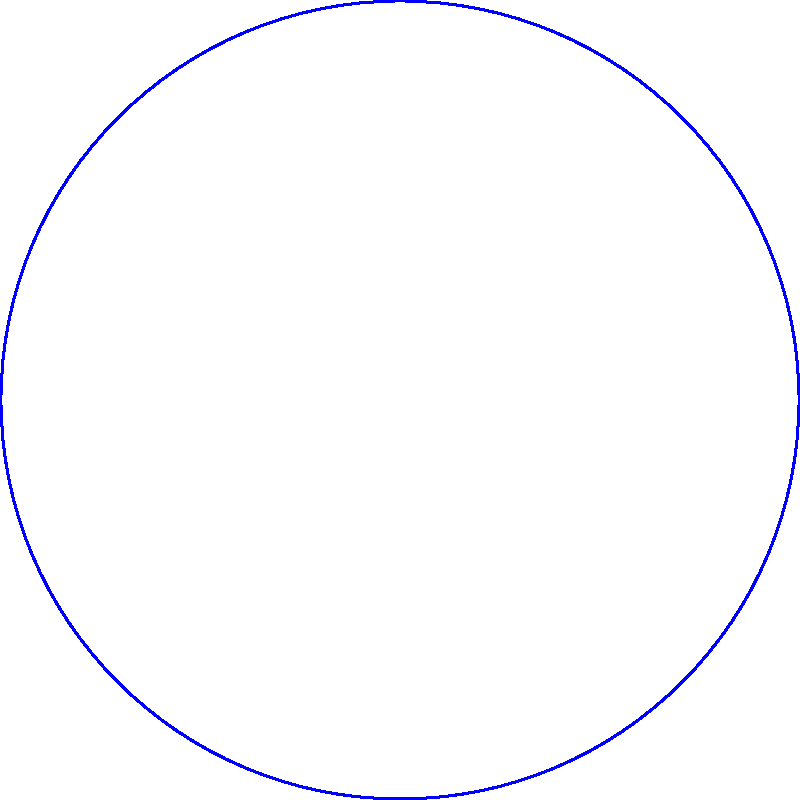Consider a positively charged particle with charge $+q$ at the origin O. The electric field lines are shown in blue. If we apply a translation of 2 units to the right, transforming the particle to point A, how would the electric field lines be affected? Describe the transformation of the field lines and explain why this occurs. To understand the transformation of electric field lines, let's follow these steps:

1) Initial configuration: The electric field lines originate radially outward from the positive charge $+q$ at the origin O.

2) Translation: The charge is moved 2 units to the right, to point A.

3) Effect on field lines:
   a) The field lines will maintain their radial pattern.
   b) The center of the radial pattern will move with the charge to point A.
   c) The field lines will not change in shape or density.

4) Explanation:
   a) Electric field lines always originate from positive charges and terminate on negative charges (or extend to infinity).
   b) The field lines represent the direction of the force experienced by a positive test charge at any point.
   c) The translation of the charge does not change its magnitude or nature, only its position.
   d) The field around a point charge is spherically symmetric, so a translation will not distort this symmetry.

5) Mathematical representation:
   If $\mathbf{E}(x,y,z)$ represents the initial electric field, the transformed field $\mathbf{E}'(x,y,z)$ would be:
   $$\mathbf{E}'(x,y,z) = \mathbf{E}(x-2,y,z)$$

This transformation is an example of the principle of superposition in electrostatics, which Professor Stehle often emphasized in his lectures.
Answer: The electric field lines translate 2 units right, maintaining their radial pattern centered at the new charge position. 